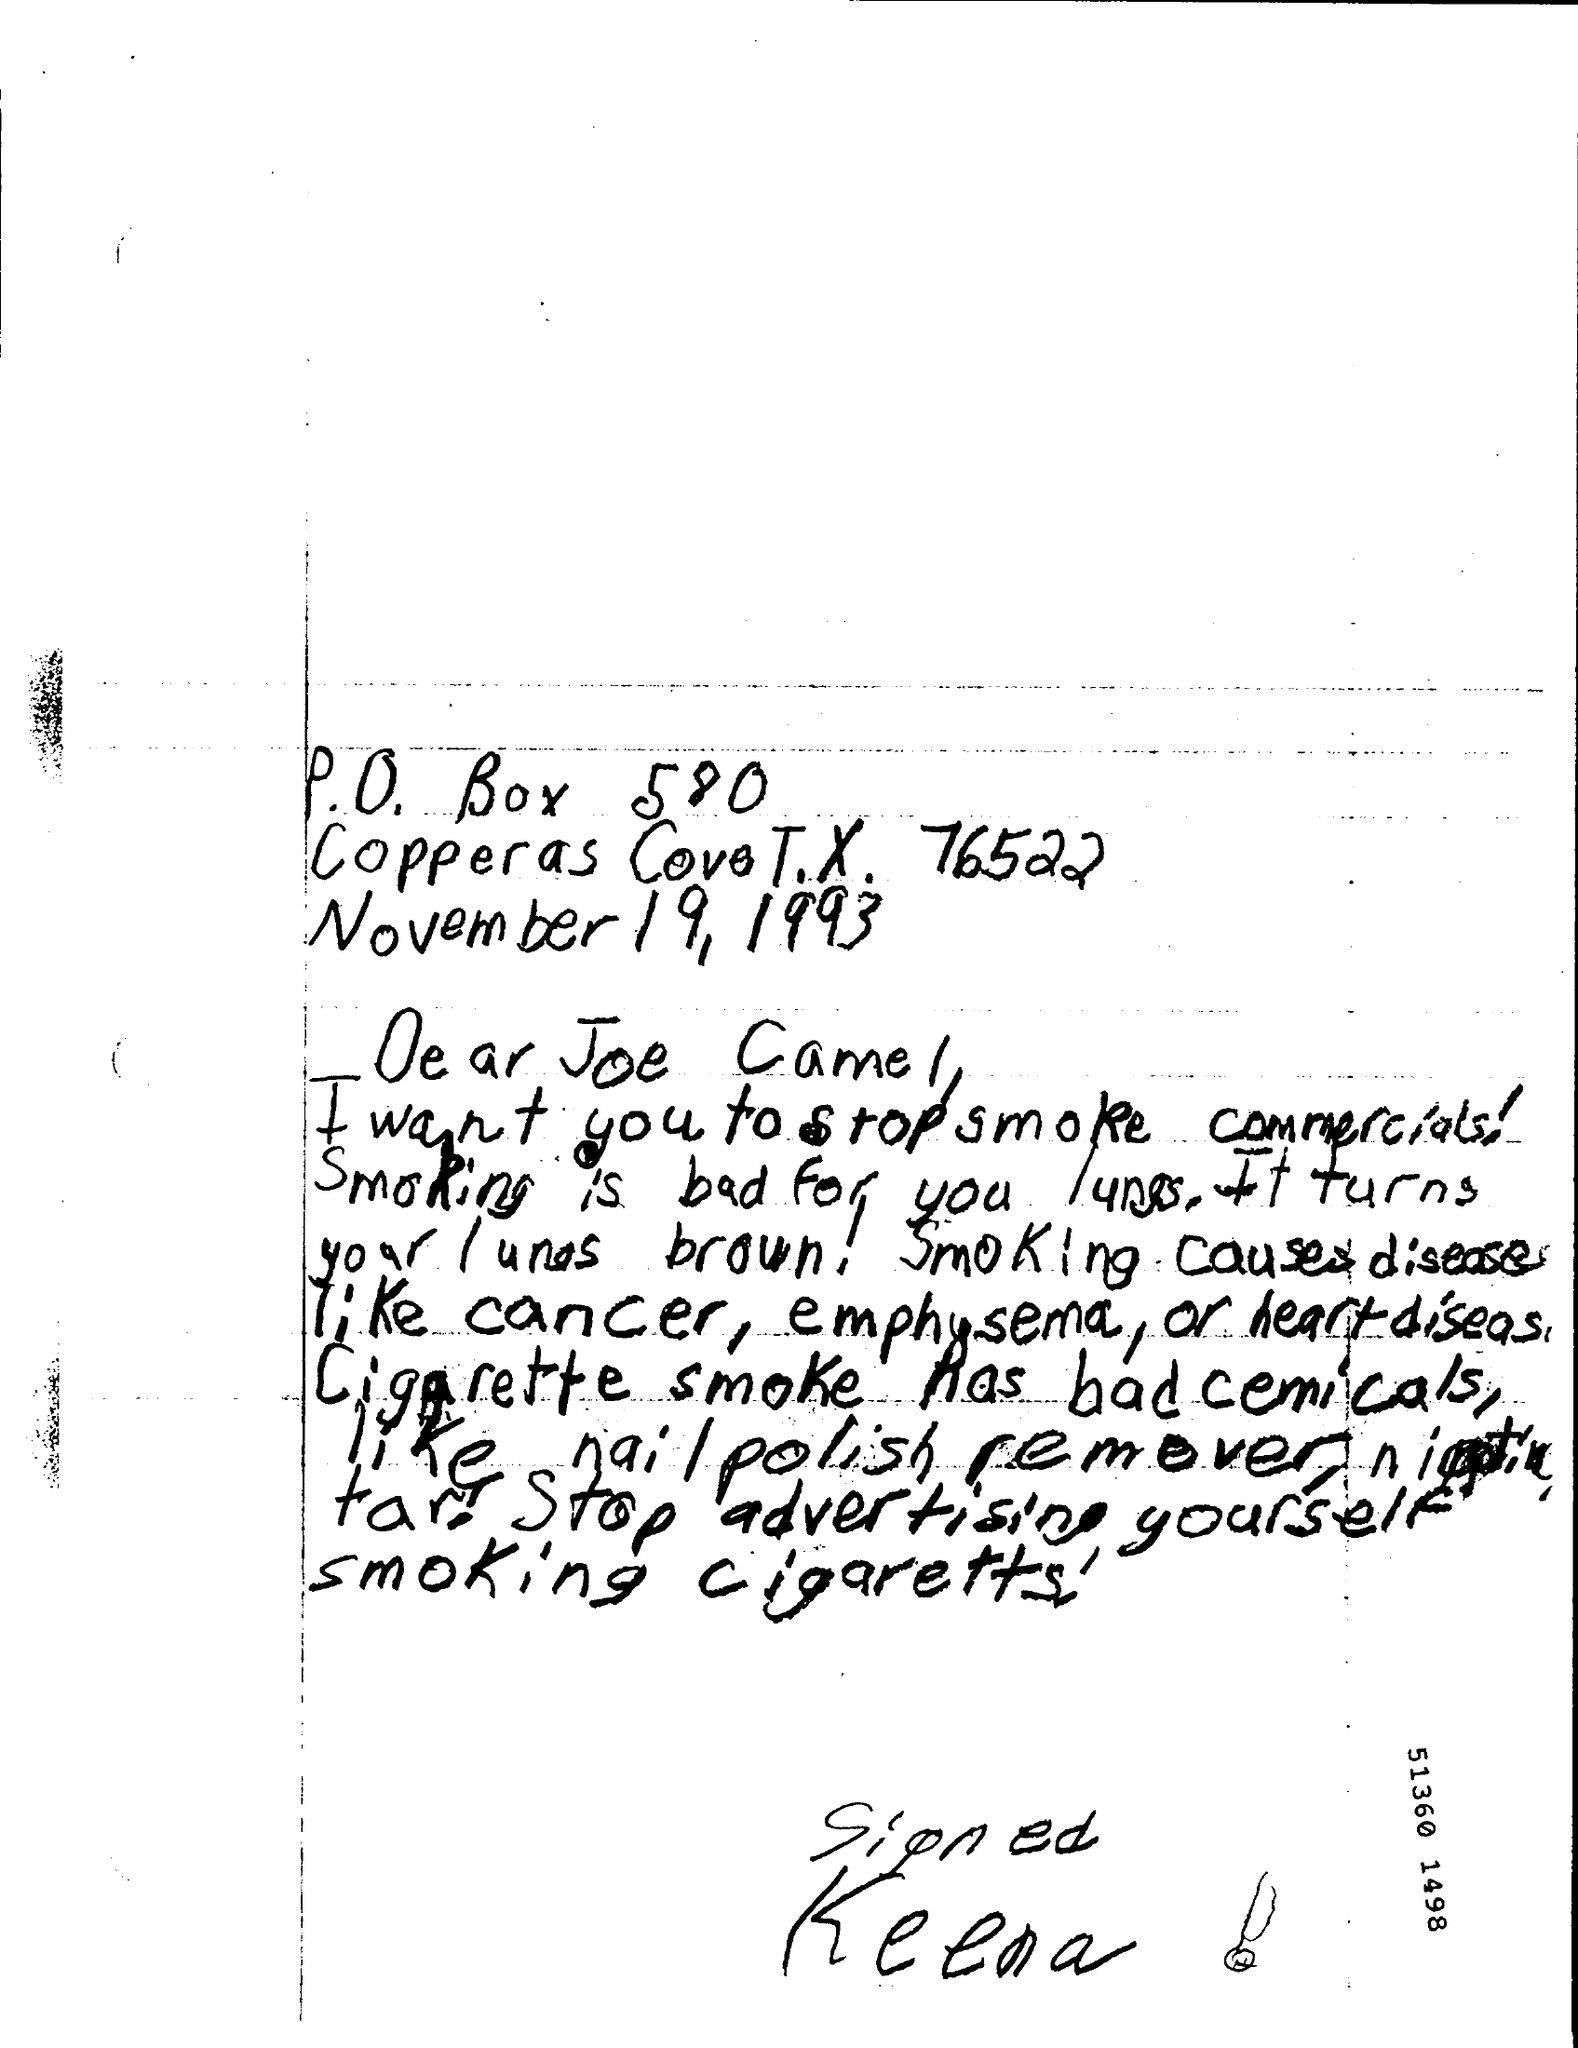Indicate a few pertinent items in this graphic. The date is November 19, 1993. The letter is addressed to the person named Joe Camel. 